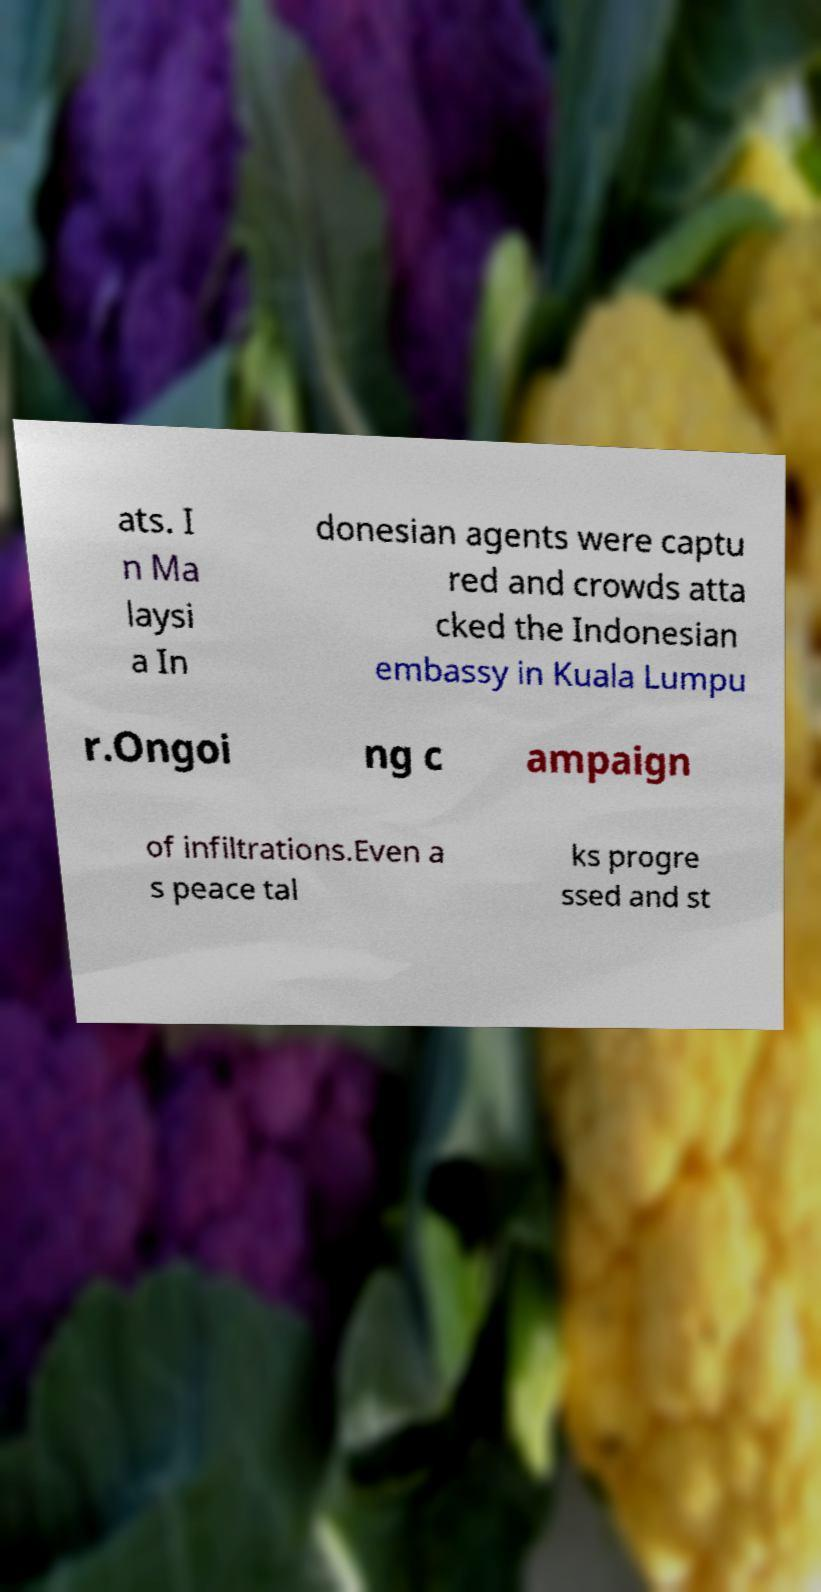Can you read and provide the text displayed in the image?This photo seems to have some interesting text. Can you extract and type it out for me? ats. I n Ma laysi a In donesian agents were captu red and crowds atta cked the Indonesian embassy in Kuala Lumpu r.Ongoi ng c ampaign of infiltrations.Even a s peace tal ks progre ssed and st 